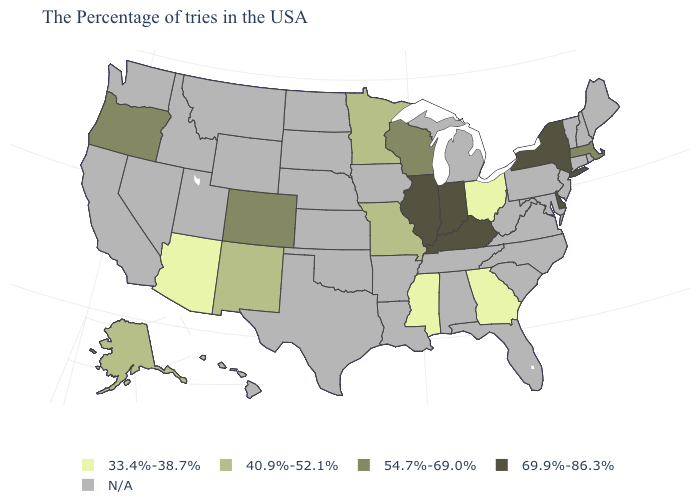What is the lowest value in states that border Utah?
Short answer required. 33.4%-38.7%. Does the first symbol in the legend represent the smallest category?
Give a very brief answer. Yes. What is the lowest value in states that border New York?
Quick response, please. 54.7%-69.0%. Does the map have missing data?
Be succinct. Yes. Name the states that have a value in the range N/A?
Answer briefly. Maine, Rhode Island, New Hampshire, Vermont, Connecticut, New Jersey, Maryland, Pennsylvania, Virginia, North Carolina, South Carolina, West Virginia, Florida, Michigan, Alabama, Tennessee, Louisiana, Arkansas, Iowa, Kansas, Nebraska, Oklahoma, Texas, South Dakota, North Dakota, Wyoming, Utah, Montana, Idaho, Nevada, California, Washington, Hawaii. What is the value of Arkansas?
Concise answer only. N/A. Which states have the lowest value in the USA?
Keep it brief. Ohio, Georgia, Mississippi, Arizona. Which states hav the highest value in the South?
Give a very brief answer. Delaware, Kentucky. Name the states that have a value in the range 69.9%-86.3%?
Give a very brief answer. New York, Delaware, Kentucky, Indiana, Illinois. What is the value of Montana?
Keep it brief. N/A. Does Missouri have the highest value in the USA?
Answer briefly. No. Among the states that border Arizona , does New Mexico have the highest value?
Answer briefly. No. Name the states that have a value in the range 54.7%-69.0%?
Give a very brief answer. Massachusetts, Wisconsin, Colorado, Oregon. 